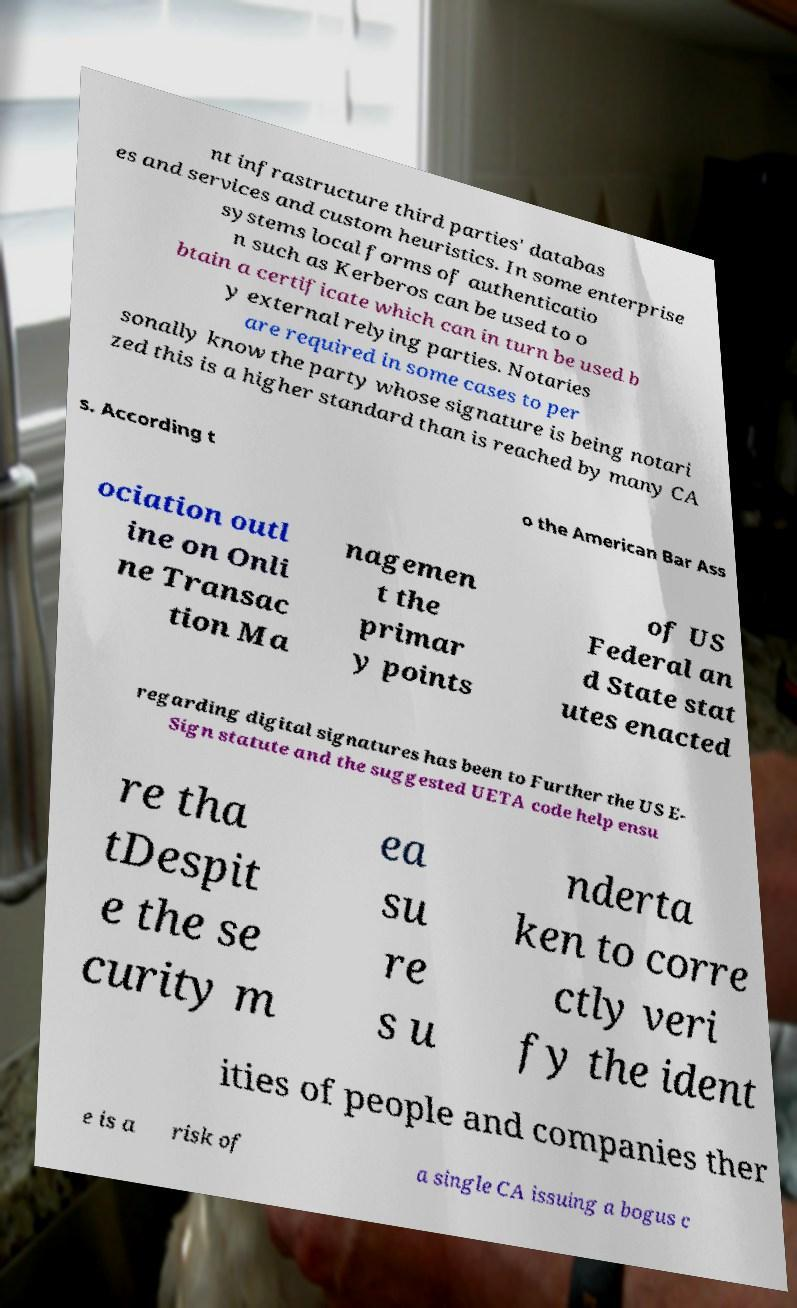Can you read and provide the text displayed in the image?This photo seems to have some interesting text. Can you extract and type it out for me? nt infrastructure third parties' databas es and services and custom heuristics. In some enterprise systems local forms of authenticatio n such as Kerberos can be used to o btain a certificate which can in turn be used b y external relying parties. Notaries are required in some cases to per sonally know the party whose signature is being notari zed this is a higher standard than is reached by many CA s. According t o the American Bar Ass ociation outl ine on Onli ne Transac tion Ma nagemen t the primar y points of US Federal an d State stat utes enacted regarding digital signatures has been to Further the US E- Sign statute and the suggested UETA code help ensu re tha tDespit e the se curity m ea su re s u nderta ken to corre ctly veri fy the ident ities of people and companies ther e is a risk of a single CA issuing a bogus c 